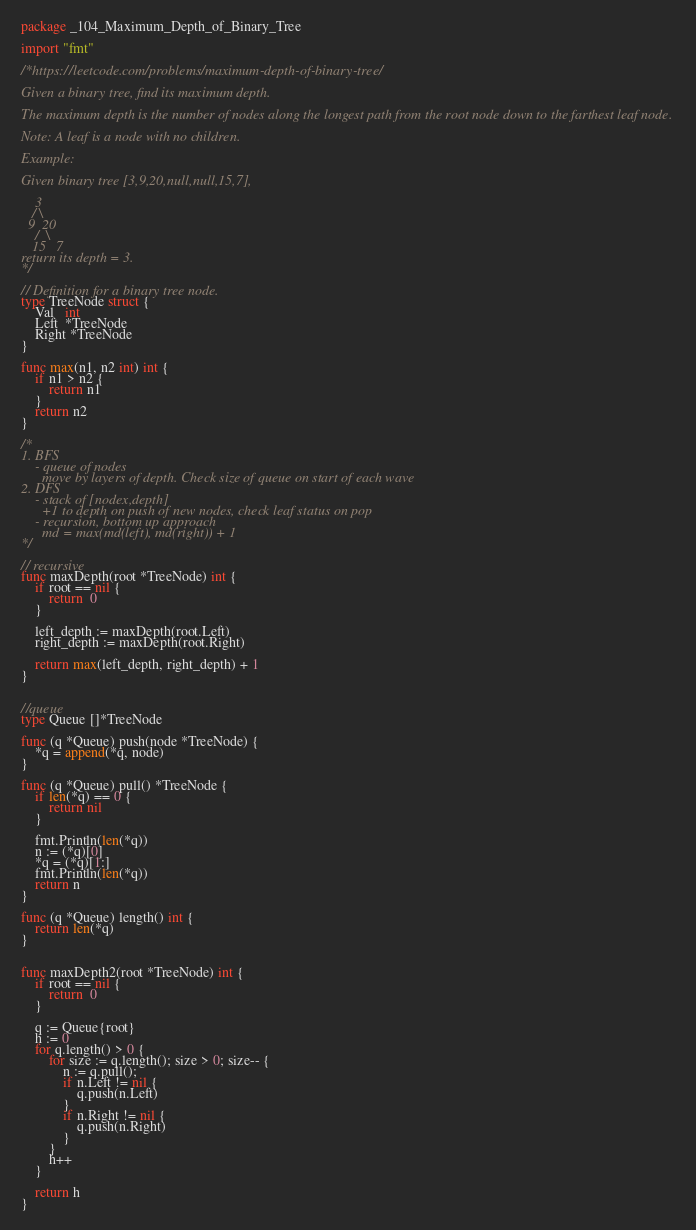<code> <loc_0><loc_0><loc_500><loc_500><_Go_>package _104_Maximum_Depth_of_Binary_Tree

import "fmt"

/*https://leetcode.com/problems/maximum-depth-of-binary-tree/

Given a binary tree, find its maximum depth.

The maximum depth is the number of nodes along the longest path from the root node down to the farthest leaf node.

Note: A leaf is a node with no children.

Example:

Given binary tree [3,9,20,null,null,15,7],

    3
   / \
  9  20
    /  \
   15   7
return its depth = 3.
*/

// Definition for a binary tree node.
type TreeNode struct {
    Val   int
    Left  *TreeNode
    Right *TreeNode
}

func max(n1, n2 int) int {
    if n1 > n2 {
        return n1
    }
    return n2
}

/*
1. BFS
    - queue of nodes
      move by layers of depth. Check size of queue on start of each wave
2. DFS
    - stack of [nodex,depth]
      +1 to depth on push of new nodes, check leaf status on pop
    - recursion, bottom up approach
      md = max(md(left), md(right)) + 1
*/

// recursive
func maxDepth(root *TreeNode) int {
    if root == nil {
        return  0
    }

    left_depth := maxDepth(root.Left)
    right_depth := maxDepth(root.Right)

    return max(left_depth, right_depth) + 1
}


//queue
type Queue []*TreeNode

func (q *Queue) push(node *TreeNode) {
    *q = append(*q, node)
}

func (q *Queue) pull() *TreeNode {
    if len(*q) == 0 {
        return nil
    }

    fmt.Println(len(*q))
    n := (*q)[0]
    *q = (*q)[1:]
    fmt.Println(len(*q))
    return n
}

func (q *Queue) length() int {
    return len(*q)
}


func maxDepth2(root *TreeNode) int {
    if root == nil {
        return  0
    }

    q := Queue{root}
    h := 0
    for q.length() > 0 {
        for size := q.length(); size > 0; size-- {
            n := q.pull();
            if n.Left != nil {
                q.push(n.Left)
            }
            if n.Right != nil {
                q.push(n.Right)
            }
        }
        h++
    }

    return h
}</code> 